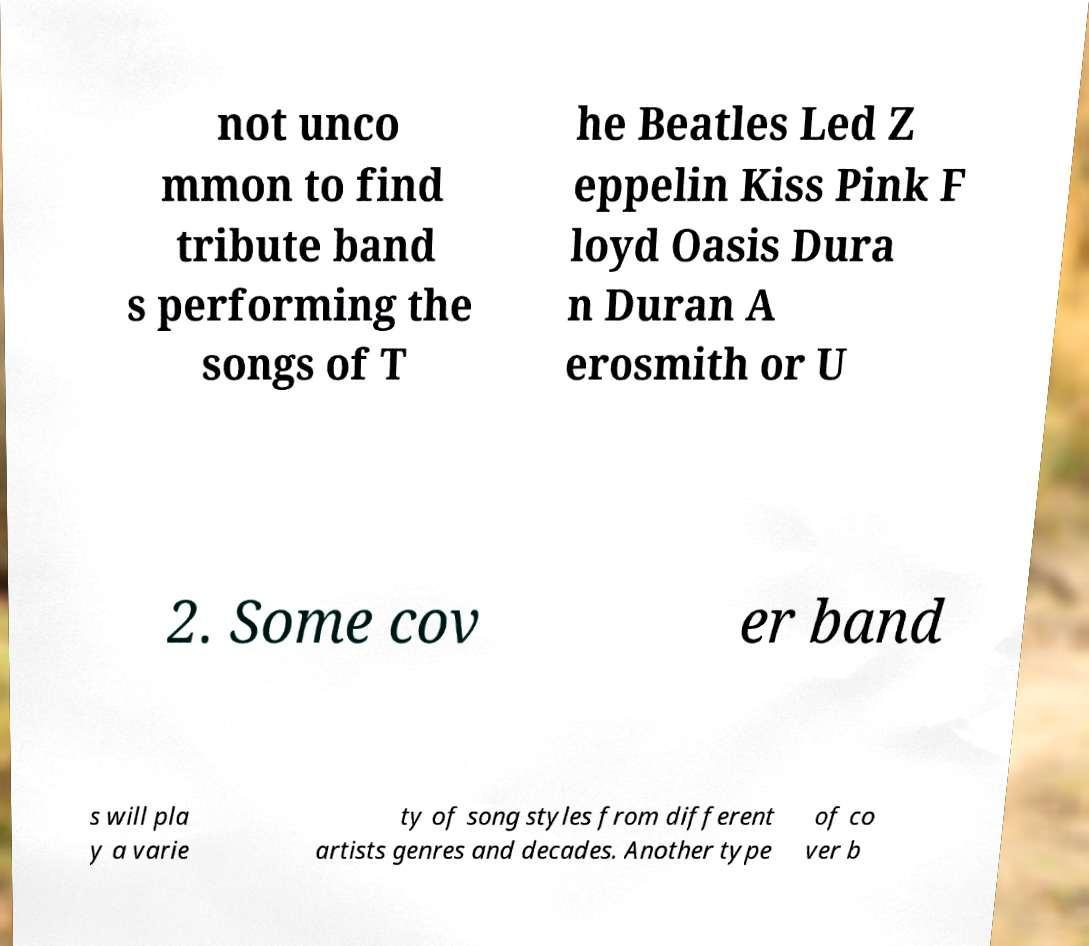Can you read and provide the text displayed in the image?This photo seems to have some interesting text. Can you extract and type it out for me? not unco mmon to find tribute band s performing the songs of T he Beatles Led Z eppelin Kiss Pink F loyd Oasis Dura n Duran A erosmith or U 2. Some cov er band s will pla y a varie ty of song styles from different artists genres and decades. Another type of co ver b 